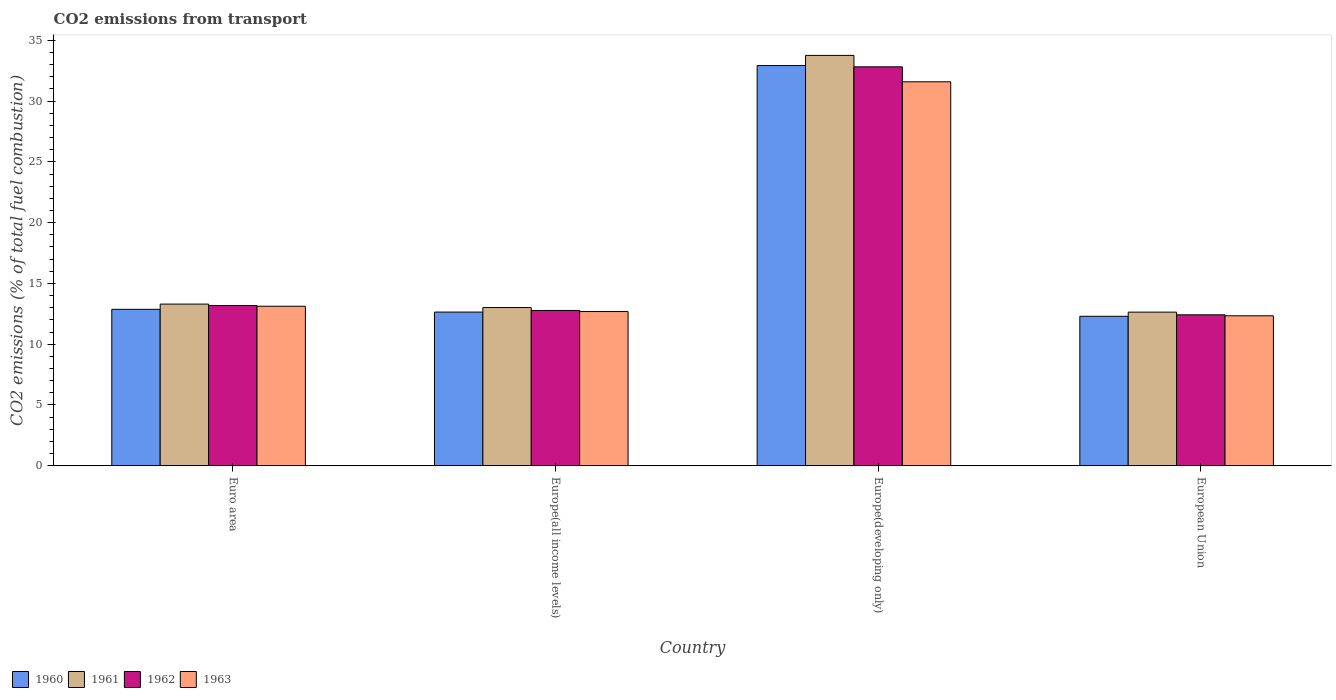How many groups of bars are there?
Make the answer very short. 4. How many bars are there on the 4th tick from the left?
Your response must be concise. 4. What is the label of the 1st group of bars from the left?
Ensure brevity in your answer.  Euro area. In how many cases, is the number of bars for a given country not equal to the number of legend labels?
Your response must be concise. 0. What is the total CO2 emitted in 1960 in Euro area?
Your answer should be very brief. 12.87. Across all countries, what is the maximum total CO2 emitted in 1961?
Make the answer very short. 33.76. Across all countries, what is the minimum total CO2 emitted in 1962?
Keep it short and to the point. 12.42. In which country was the total CO2 emitted in 1960 maximum?
Your response must be concise. Europe(developing only). In which country was the total CO2 emitted in 1960 minimum?
Provide a succinct answer. European Union. What is the total total CO2 emitted in 1961 in the graph?
Offer a very short reply. 72.72. What is the difference between the total CO2 emitted in 1963 in Euro area and that in Europe(developing only)?
Provide a short and direct response. -18.47. What is the difference between the total CO2 emitted in 1961 in European Union and the total CO2 emitted in 1963 in Europe(developing only)?
Provide a short and direct response. -18.95. What is the average total CO2 emitted in 1963 per country?
Make the answer very short. 17.44. What is the difference between the total CO2 emitted of/in 1961 and total CO2 emitted of/in 1962 in Europe(all income levels)?
Give a very brief answer. 0.24. What is the ratio of the total CO2 emitted in 1961 in Europe(all income levels) to that in Europe(developing only)?
Your answer should be very brief. 0.39. Is the difference between the total CO2 emitted in 1961 in Europe(developing only) and European Union greater than the difference between the total CO2 emitted in 1962 in Europe(developing only) and European Union?
Your response must be concise. Yes. What is the difference between the highest and the second highest total CO2 emitted in 1963?
Give a very brief answer. -0.44. What is the difference between the highest and the lowest total CO2 emitted in 1960?
Offer a very short reply. 20.63. In how many countries, is the total CO2 emitted in 1961 greater than the average total CO2 emitted in 1961 taken over all countries?
Provide a short and direct response. 1. Is it the case that in every country, the sum of the total CO2 emitted in 1960 and total CO2 emitted in 1961 is greater than the sum of total CO2 emitted in 1962 and total CO2 emitted in 1963?
Give a very brief answer. No. What does the 3rd bar from the left in Euro area represents?
Keep it short and to the point. 1962. Are all the bars in the graph horizontal?
Your response must be concise. No. How many countries are there in the graph?
Keep it short and to the point. 4. What is the difference between two consecutive major ticks on the Y-axis?
Your answer should be very brief. 5. Are the values on the major ticks of Y-axis written in scientific E-notation?
Your response must be concise. No. Where does the legend appear in the graph?
Your answer should be very brief. Bottom left. What is the title of the graph?
Keep it short and to the point. CO2 emissions from transport. What is the label or title of the X-axis?
Keep it short and to the point. Country. What is the label or title of the Y-axis?
Provide a short and direct response. CO2 emissions (% of total fuel combustion). What is the CO2 emissions (% of total fuel combustion) in 1960 in Euro area?
Provide a succinct answer. 12.87. What is the CO2 emissions (% of total fuel combustion) of 1961 in Euro area?
Keep it short and to the point. 13.3. What is the CO2 emissions (% of total fuel combustion) of 1962 in Euro area?
Provide a succinct answer. 13.18. What is the CO2 emissions (% of total fuel combustion) of 1963 in Euro area?
Provide a succinct answer. 13.12. What is the CO2 emissions (% of total fuel combustion) of 1960 in Europe(all income levels)?
Provide a succinct answer. 12.64. What is the CO2 emissions (% of total fuel combustion) in 1961 in Europe(all income levels)?
Provide a short and direct response. 13.01. What is the CO2 emissions (% of total fuel combustion) of 1962 in Europe(all income levels)?
Your answer should be compact. 12.78. What is the CO2 emissions (% of total fuel combustion) in 1963 in Europe(all income levels)?
Offer a terse response. 12.69. What is the CO2 emissions (% of total fuel combustion) of 1960 in Europe(developing only)?
Offer a terse response. 32.93. What is the CO2 emissions (% of total fuel combustion) of 1961 in Europe(developing only)?
Offer a very short reply. 33.76. What is the CO2 emissions (% of total fuel combustion) of 1962 in Europe(developing only)?
Your answer should be very brief. 32.82. What is the CO2 emissions (% of total fuel combustion) of 1963 in Europe(developing only)?
Provide a succinct answer. 31.59. What is the CO2 emissions (% of total fuel combustion) of 1960 in European Union?
Ensure brevity in your answer.  12.3. What is the CO2 emissions (% of total fuel combustion) of 1961 in European Union?
Offer a terse response. 12.64. What is the CO2 emissions (% of total fuel combustion) of 1962 in European Union?
Keep it short and to the point. 12.42. What is the CO2 emissions (% of total fuel combustion) in 1963 in European Union?
Provide a succinct answer. 12.34. Across all countries, what is the maximum CO2 emissions (% of total fuel combustion) of 1960?
Offer a terse response. 32.93. Across all countries, what is the maximum CO2 emissions (% of total fuel combustion) in 1961?
Your response must be concise. 33.76. Across all countries, what is the maximum CO2 emissions (% of total fuel combustion) of 1962?
Make the answer very short. 32.82. Across all countries, what is the maximum CO2 emissions (% of total fuel combustion) of 1963?
Keep it short and to the point. 31.59. Across all countries, what is the minimum CO2 emissions (% of total fuel combustion) in 1960?
Offer a very short reply. 12.3. Across all countries, what is the minimum CO2 emissions (% of total fuel combustion) in 1961?
Offer a very short reply. 12.64. Across all countries, what is the minimum CO2 emissions (% of total fuel combustion) in 1962?
Your answer should be compact. 12.42. Across all countries, what is the minimum CO2 emissions (% of total fuel combustion) in 1963?
Make the answer very short. 12.34. What is the total CO2 emissions (% of total fuel combustion) of 1960 in the graph?
Provide a short and direct response. 70.74. What is the total CO2 emissions (% of total fuel combustion) of 1961 in the graph?
Give a very brief answer. 72.72. What is the total CO2 emissions (% of total fuel combustion) in 1962 in the graph?
Offer a very short reply. 71.2. What is the total CO2 emissions (% of total fuel combustion) of 1963 in the graph?
Ensure brevity in your answer.  69.74. What is the difference between the CO2 emissions (% of total fuel combustion) of 1960 in Euro area and that in Europe(all income levels)?
Your answer should be very brief. 0.23. What is the difference between the CO2 emissions (% of total fuel combustion) in 1961 in Euro area and that in Europe(all income levels)?
Offer a terse response. 0.29. What is the difference between the CO2 emissions (% of total fuel combustion) in 1962 in Euro area and that in Europe(all income levels)?
Offer a terse response. 0.41. What is the difference between the CO2 emissions (% of total fuel combustion) in 1963 in Euro area and that in Europe(all income levels)?
Provide a short and direct response. 0.44. What is the difference between the CO2 emissions (% of total fuel combustion) in 1960 in Euro area and that in Europe(developing only)?
Keep it short and to the point. -20.06. What is the difference between the CO2 emissions (% of total fuel combustion) of 1961 in Euro area and that in Europe(developing only)?
Give a very brief answer. -20.46. What is the difference between the CO2 emissions (% of total fuel combustion) in 1962 in Euro area and that in Europe(developing only)?
Provide a succinct answer. -19.64. What is the difference between the CO2 emissions (% of total fuel combustion) of 1963 in Euro area and that in Europe(developing only)?
Ensure brevity in your answer.  -18.47. What is the difference between the CO2 emissions (% of total fuel combustion) of 1960 in Euro area and that in European Union?
Your answer should be compact. 0.57. What is the difference between the CO2 emissions (% of total fuel combustion) of 1961 in Euro area and that in European Union?
Make the answer very short. 0.66. What is the difference between the CO2 emissions (% of total fuel combustion) of 1962 in Euro area and that in European Union?
Provide a succinct answer. 0.76. What is the difference between the CO2 emissions (% of total fuel combustion) of 1963 in Euro area and that in European Union?
Ensure brevity in your answer.  0.79. What is the difference between the CO2 emissions (% of total fuel combustion) of 1960 in Europe(all income levels) and that in Europe(developing only)?
Keep it short and to the point. -20.28. What is the difference between the CO2 emissions (% of total fuel combustion) in 1961 in Europe(all income levels) and that in Europe(developing only)?
Provide a succinct answer. -20.75. What is the difference between the CO2 emissions (% of total fuel combustion) of 1962 in Europe(all income levels) and that in Europe(developing only)?
Give a very brief answer. -20.05. What is the difference between the CO2 emissions (% of total fuel combustion) of 1963 in Europe(all income levels) and that in Europe(developing only)?
Provide a succinct answer. -18.9. What is the difference between the CO2 emissions (% of total fuel combustion) of 1960 in Europe(all income levels) and that in European Union?
Your answer should be very brief. 0.35. What is the difference between the CO2 emissions (% of total fuel combustion) of 1961 in Europe(all income levels) and that in European Union?
Offer a very short reply. 0.38. What is the difference between the CO2 emissions (% of total fuel combustion) of 1962 in Europe(all income levels) and that in European Union?
Your response must be concise. 0.36. What is the difference between the CO2 emissions (% of total fuel combustion) in 1963 in Europe(all income levels) and that in European Union?
Provide a succinct answer. 0.35. What is the difference between the CO2 emissions (% of total fuel combustion) of 1960 in Europe(developing only) and that in European Union?
Make the answer very short. 20.63. What is the difference between the CO2 emissions (% of total fuel combustion) of 1961 in Europe(developing only) and that in European Union?
Give a very brief answer. 21.13. What is the difference between the CO2 emissions (% of total fuel combustion) of 1962 in Europe(developing only) and that in European Union?
Your answer should be compact. 20.41. What is the difference between the CO2 emissions (% of total fuel combustion) of 1963 in Europe(developing only) and that in European Union?
Keep it short and to the point. 19.25. What is the difference between the CO2 emissions (% of total fuel combustion) in 1960 in Euro area and the CO2 emissions (% of total fuel combustion) in 1961 in Europe(all income levels)?
Your answer should be very brief. -0.14. What is the difference between the CO2 emissions (% of total fuel combustion) of 1960 in Euro area and the CO2 emissions (% of total fuel combustion) of 1962 in Europe(all income levels)?
Keep it short and to the point. 0.09. What is the difference between the CO2 emissions (% of total fuel combustion) in 1960 in Euro area and the CO2 emissions (% of total fuel combustion) in 1963 in Europe(all income levels)?
Ensure brevity in your answer.  0.18. What is the difference between the CO2 emissions (% of total fuel combustion) in 1961 in Euro area and the CO2 emissions (% of total fuel combustion) in 1962 in Europe(all income levels)?
Your answer should be very brief. 0.53. What is the difference between the CO2 emissions (% of total fuel combustion) of 1961 in Euro area and the CO2 emissions (% of total fuel combustion) of 1963 in Europe(all income levels)?
Your answer should be very brief. 0.61. What is the difference between the CO2 emissions (% of total fuel combustion) in 1962 in Euro area and the CO2 emissions (% of total fuel combustion) in 1963 in Europe(all income levels)?
Provide a short and direct response. 0.49. What is the difference between the CO2 emissions (% of total fuel combustion) of 1960 in Euro area and the CO2 emissions (% of total fuel combustion) of 1961 in Europe(developing only)?
Keep it short and to the point. -20.89. What is the difference between the CO2 emissions (% of total fuel combustion) in 1960 in Euro area and the CO2 emissions (% of total fuel combustion) in 1962 in Europe(developing only)?
Offer a very short reply. -19.95. What is the difference between the CO2 emissions (% of total fuel combustion) in 1960 in Euro area and the CO2 emissions (% of total fuel combustion) in 1963 in Europe(developing only)?
Keep it short and to the point. -18.72. What is the difference between the CO2 emissions (% of total fuel combustion) of 1961 in Euro area and the CO2 emissions (% of total fuel combustion) of 1962 in Europe(developing only)?
Offer a terse response. -19.52. What is the difference between the CO2 emissions (% of total fuel combustion) of 1961 in Euro area and the CO2 emissions (% of total fuel combustion) of 1963 in Europe(developing only)?
Keep it short and to the point. -18.29. What is the difference between the CO2 emissions (% of total fuel combustion) of 1962 in Euro area and the CO2 emissions (% of total fuel combustion) of 1963 in Europe(developing only)?
Give a very brief answer. -18.41. What is the difference between the CO2 emissions (% of total fuel combustion) in 1960 in Euro area and the CO2 emissions (% of total fuel combustion) in 1961 in European Union?
Offer a terse response. 0.23. What is the difference between the CO2 emissions (% of total fuel combustion) in 1960 in Euro area and the CO2 emissions (% of total fuel combustion) in 1962 in European Union?
Give a very brief answer. 0.45. What is the difference between the CO2 emissions (% of total fuel combustion) in 1960 in Euro area and the CO2 emissions (% of total fuel combustion) in 1963 in European Union?
Provide a succinct answer. 0.53. What is the difference between the CO2 emissions (% of total fuel combustion) in 1961 in Euro area and the CO2 emissions (% of total fuel combustion) in 1962 in European Union?
Your answer should be compact. 0.88. What is the difference between the CO2 emissions (% of total fuel combustion) of 1961 in Euro area and the CO2 emissions (% of total fuel combustion) of 1963 in European Union?
Give a very brief answer. 0.96. What is the difference between the CO2 emissions (% of total fuel combustion) in 1962 in Euro area and the CO2 emissions (% of total fuel combustion) in 1963 in European Union?
Offer a very short reply. 0.84. What is the difference between the CO2 emissions (% of total fuel combustion) of 1960 in Europe(all income levels) and the CO2 emissions (% of total fuel combustion) of 1961 in Europe(developing only)?
Offer a very short reply. -21.12. What is the difference between the CO2 emissions (% of total fuel combustion) in 1960 in Europe(all income levels) and the CO2 emissions (% of total fuel combustion) in 1962 in Europe(developing only)?
Your response must be concise. -20.18. What is the difference between the CO2 emissions (% of total fuel combustion) of 1960 in Europe(all income levels) and the CO2 emissions (% of total fuel combustion) of 1963 in Europe(developing only)?
Ensure brevity in your answer.  -18.95. What is the difference between the CO2 emissions (% of total fuel combustion) of 1961 in Europe(all income levels) and the CO2 emissions (% of total fuel combustion) of 1962 in Europe(developing only)?
Provide a succinct answer. -19.81. What is the difference between the CO2 emissions (% of total fuel combustion) in 1961 in Europe(all income levels) and the CO2 emissions (% of total fuel combustion) in 1963 in Europe(developing only)?
Your response must be concise. -18.58. What is the difference between the CO2 emissions (% of total fuel combustion) in 1962 in Europe(all income levels) and the CO2 emissions (% of total fuel combustion) in 1963 in Europe(developing only)?
Your response must be concise. -18.82. What is the difference between the CO2 emissions (% of total fuel combustion) of 1960 in Europe(all income levels) and the CO2 emissions (% of total fuel combustion) of 1961 in European Union?
Offer a terse response. 0.01. What is the difference between the CO2 emissions (% of total fuel combustion) of 1960 in Europe(all income levels) and the CO2 emissions (% of total fuel combustion) of 1962 in European Union?
Keep it short and to the point. 0.23. What is the difference between the CO2 emissions (% of total fuel combustion) of 1960 in Europe(all income levels) and the CO2 emissions (% of total fuel combustion) of 1963 in European Union?
Provide a succinct answer. 0.31. What is the difference between the CO2 emissions (% of total fuel combustion) of 1961 in Europe(all income levels) and the CO2 emissions (% of total fuel combustion) of 1962 in European Union?
Your answer should be very brief. 0.6. What is the difference between the CO2 emissions (% of total fuel combustion) of 1961 in Europe(all income levels) and the CO2 emissions (% of total fuel combustion) of 1963 in European Union?
Offer a very short reply. 0.68. What is the difference between the CO2 emissions (% of total fuel combustion) of 1962 in Europe(all income levels) and the CO2 emissions (% of total fuel combustion) of 1963 in European Union?
Your answer should be very brief. 0.44. What is the difference between the CO2 emissions (% of total fuel combustion) of 1960 in Europe(developing only) and the CO2 emissions (% of total fuel combustion) of 1961 in European Union?
Give a very brief answer. 20.29. What is the difference between the CO2 emissions (% of total fuel combustion) of 1960 in Europe(developing only) and the CO2 emissions (% of total fuel combustion) of 1962 in European Union?
Make the answer very short. 20.51. What is the difference between the CO2 emissions (% of total fuel combustion) in 1960 in Europe(developing only) and the CO2 emissions (% of total fuel combustion) in 1963 in European Union?
Your answer should be very brief. 20.59. What is the difference between the CO2 emissions (% of total fuel combustion) of 1961 in Europe(developing only) and the CO2 emissions (% of total fuel combustion) of 1962 in European Union?
Offer a terse response. 21.35. What is the difference between the CO2 emissions (% of total fuel combustion) of 1961 in Europe(developing only) and the CO2 emissions (% of total fuel combustion) of 1963 in European Union?
Ensure brevity in your answer.  21.43. What is the difference between the CO2 emissions (% of total fuel combustion) of 1962 in Europe(developing only) and the CO2 emissions (% of total fuel combustion) of 1963 in European Union?
Make the answer very short. 20.49. What is the average CO2 emissions (% of total fuel combustion) in 1960 per country?
Offer a terse response. 17.68. What is the average CO2 emissions (% of total fuel combustion) in 1961 per country?
Keep it short and to the point. 18.18. What is the average CO2 emissions (% of total fuel combustion) in 1962 per country?
Provide a short and direct response. 17.8. What is the average CO2 emissions (% of total fuel combustion) of 1963 per country?
Provide a short and direct response. 17.44. What is the difference between the CO2 emissions (% of total fuel combustion) of 1960 and CO2 emissions (% of total fuel combustion) of 1961 in Euro area?
Provide a succinct answer. -0.43. What is the difference between the CO2 emissions (% of total fuel combustion) of 1960 and CO2 emissions (% of total fuel combustion) of 1962 in Euro area?
Your answer should be very brief. -0.31. What is the difference between the CO2 emissions (% of total fuel combustion) of 1960 and CO2 emissions (% of total fuel combustion) of 1963 in Euro area?
Make the answer very short. -0.25. What is the difference between the CO2 emissions (% of total fuel combustion) of 1961 and CO2 emissions (% of total fuel combustion) of 1962 in Euro area?
Your response must be concise. 0.12. What is the difference between the CO2 emissions (% of total fuel combustion) in 1961 and CO2 emissions (% of total fuel combustion) in 1963 in Euro area?
Your answer should be compact. 0.18. What is the difference between the CO2 emissions (% of total fuel combustion) of 1962 and CO2 emissions (% of total fuel combustion) of 1963 in Euro area?
Your answer should be very brief. 0.06. What is the difference between the CO2 emissions (% of total fuel combustion) in 1960 and CO2 emissions (% of total fuel combustion) in 1961 in Europe(all income levels)?
Your answer should be very brief. -0.37. What is the difference between the CO2 emissions (% of total fuel combustion) of 1960 and CO2 emissions (% of total fuel combustion) of 1962 in Europe(all income levels)?
Give a very brief answer. -0.13. What is the difference between the CO2 emissions (% of total fuel combustion) in 1960 and CO2 emissions (% of total fuel combustion) in 1963 in Europe(all income levels)?
Your response must be concise. -0.04. What is the difference between the CO2 emissions (% of total fuel combustion) in 1961 and CO2 emissions (% of total fuel combustion) in 1962 in Europe(all income levels)?
Provide a succinct answer. 0.24. What is the difference between the CO2 emissions (% of total fuel combustion) in 1961 and CO2 emissions (% of total fuel combustion) in 1963 in Europe(all income levels)?
Provide a short and direct response. 0.33. What is the difference between the CO2 emissions (% of total fuel combustion) of 1962 and CO2 emissions (% of total fuel combustion) of 1963 in Europe(all income levels)?
Your answer should be very brief. 0.09. What is the difference between the CO2 emissions (% of total fuel combustion) in 1960 and CO2 emissions (% of total fuel combustion) in 1961 in Europe(developing only)?
Make the answer very short. -0.84. What is the difference between the CO2 emissions (% of total fuel combustion) in 1960 and CO2 emissions (% of total fuel combustion) in 1962 in Europe(developing only)?
Your answer should be very brief. 0.1. What is the difference between the CO2 emissions (% of total fuel combustion) in 1960 and CO2 emissions (% of total fuel combustion) in 1963 in Europe(developing only)?
Give a very brief answer. 1.34. What is the difference between the CO2 emissions (% of total fuel combustion) of 1961 and CO2 emissions (% of total fuel combustion) of 1962 in Europe(developing only)?
Your response must be concise. 0.94. What is the difference between the CO2 emissions (% of total fuel combustion) in 1961 and CO2 emissions (% of total fuel combustion) in 1963 in Europe(developing only)?
Your response must be concise. 2.17. What is the difference between the CO2 emissions (% of total fuel combustion) in 1962 and CO2 emissions (% of total fuel combustion) in 1963 in Europe(developing only)?
Provide a short and direct response. 1.23. What is the difference between the CO2 emissions (% of total fuel combustion) in 1960 and CO2 emissions (% of total fuel combustion) in 1961 in European Union?
Provide a succinct answer. -0.34. What is the difference between the CO2 emissions (% of total fuel combustion) of 1960 and CO2 emissions (% of total fuel combustion) of 1962 in European Union?
Provide a short and direct response. -0.12. What is the difference between the CO2 emissions (% of total fuel combustion) in 1960 and CO2 emissions (% of total fuel combustion) in 1963 in European Union?
Make the answer very short. -0.04. What is the difference between the CO2 emissions (% of total fuel combustion) in 1961 and CO2 emissions (% of total fuel combustion) in 1962 in European Union?
Provide a succinct answer. 0.22. What is the difference between the CO2 emissions (% of total fuel combustion) in 1961 and CO2 emissions (% of total fuel combustion) in 1963 in European Union?
Offer a very short reply. 0.3. What is the difference between the CO2 emissions (% of total fuel combustion) of 1962 and CO2 emissions (% of total fuel combustion) of 1963 in European Union?
Your answer should be very brief. 0.08. What is the ratio of the CO2 emissions (% of total fuel combustion) in 1960 in Euro area to that in Europe(all income levels)?
Keep it short and to the point. 1.02. What is the ratio of the CO2 emissions (% of total fuel combustion) in 1962 in Euro area to that in Europe(all income levels)?
Keep it short and to the point. 1.03. What is the ratio of the CO2 emissions (% of total fuel combustion) of 1963 in Euro area to that in Europe(all income levels)?
Your answer should be very brief. 1.03. What is the ratio of the CO2 emissions (% of total fuel combustion) of 1960 in Euro area to that in Europe(developing only)?
Offer a very short reply. 0.39. What is the ratio of the CO2 emissions (% of total fuel combustion) in 1961 in Euro area to that in Europe(developing only)?
Give a very brief answer. 0.39. What is the ratio of the CO2 emissions (% of total fuel combustion) in 1962 in Euro area to that in Europe(developing only)?
Offer a very short reply. 0.4. What is the ratio of the CO2 emissions (% of total fuel combustion) in 1963 in Euro area to that in Europe(developing only)?
Provide a short and direct response. 0.42. What is the ratio of the CO2 emissions (% of total fuel combustion) of 1960 in Euro area to that in European Union?
Keep it short and to the point. 1.05. What is the ratio of the CO2 emissions (% of total fuel combustion) of 1961 in Euro area to that in European Union?
Your answer should be compact. 1.05. What is the ratio of the CO2 emissions (% of total fuel combustion) of 1962 in Euro area to that in European Union?
Give a very brief answer. 1.06. What is the ratio of the CO2 emissions (% of total fuel combustion) in 1963 in Euro area to that in European Union?
Keep it short and to the point. 1.06. What is the ratio of the CO2 emissions (% of total fuel combustion) in 1960 in Europe(all income levels) to that in Europe(developing only)?
Your response must be concise. 0.38. What is the ratio of the CO2 emissions (% of total fuel combustion) of 1961 in Europe(all income levels) to that in Europe(developing only)?
Make the answer very short. 0.39. What is the ratio of the CO2 emissions (% of total fuel combustion) in 1962 in Europe(all income levels) to that in Europe(developing only)?
Offer a terse response. 0.39. What is the ratio of the CO2 emissions (% of total fuel combustion) in 1963 in Europe(all income levels) to that in Europe(developing only)?
Offer a terse response. 0.4. What is the ratio of the CO2 emissions (% of total fuel combustion) of 1960 in Europe(all income levels) to that in European Union?
Ensure brevity in your answer.  1.03. What is the ratio of the CO2 emissions (% of total fuel combustion) in 1961 in Europe(all income levels) to that in European Union?
Make the answer very short. 1.03. What is the ratio of the CO2 emissions (% of total fuel combustion) in 1962 in Europe(all income levels) to that in European Union?
Give a very brief answer. 1.03. What is the ratio of the CO2 emissions (% of total fuel combustion) in 1963 in Europe(all income levels) to that in European Union?
Keep it short and to the point. 1.03. What is the ratio of the CO2 emissions (% of total fuel combustion) of 1960 in Europe(developing only) to that in European Union?
Keep it short and to the point. 2.68. What is the ratio of the CO2 emissions (% of total fuel combustion) of 1961 in Europe(developing only) to that in European Union?
Provide a succinct answer. 2.67. What is the ratio of the CO2 emissions (% of total fuel combustion) of 1962 in Europe(developing only) to that in European Union?
Your answer should be compact. 2.64. What is the ratio of the CO2 emissions (% of total fuel combustion) of 1963 in Europe(developing only) to that in European Union?
Offer a very short reply. 2.56. What is the difference between the highest and the second highest CO2 emissions (% of total fuel combustion) in 1960?
Make the answer very short. 20.06. What is the difference between the highest and the second highest CO2 emissions (% of total fuel combustion) of 1961?
Give a very brief answer. 20.46. What is the difference between the highest and the second highest CO2 emissions (% of total fuel combustion) in 1962?
Keep it short and to the point. 19.64. What is the difference between the highest and the second highest CO2 emissions (% of total fuel combustion) of 1963?
Offer a terse response. 18.47. What is the difference between the highest and the lowest CO2 emissions (% of total fuel combustion) in 1960?
Offer a very short reply. 20.63. What is the difference between the highest and the lowest CO2 emissions (% of total fuel combustion) in 1961?
Give a very brief answer. 21.13. What is the difference between the highest and the lowest CO2 emissions (% of total fuel combustion) in 1962?
Make the answer very short. 20.41. What is the difference between the highest and the lowest CO2 emissions (% of total fuel combustion) of 1963?
Offer a very short reply. 19.25. 